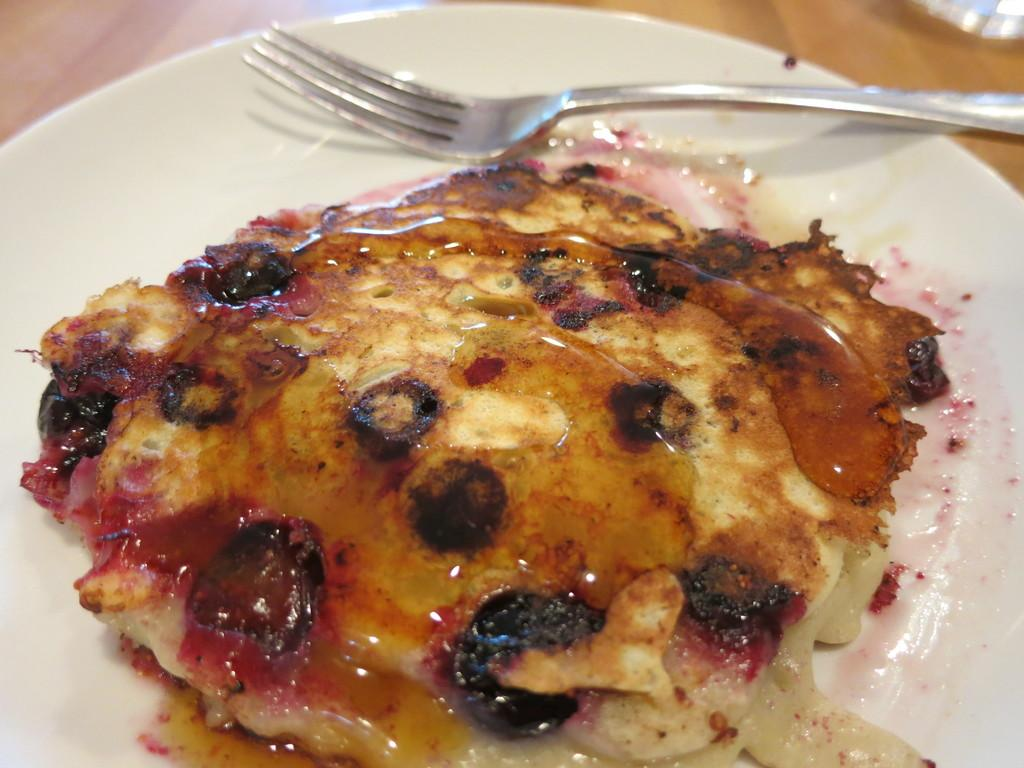What type of surface is present in the image? There is a wooden platform in the image. What is on the wooden platform? There is food on a plate on the wooden platform. What utensil is present with the food? There is a fork on the plate with the food. What type of bean is growing on the wooden platform in the image? There is no bean present in the image; it features a wooden platform with a plate of food and a fork. 